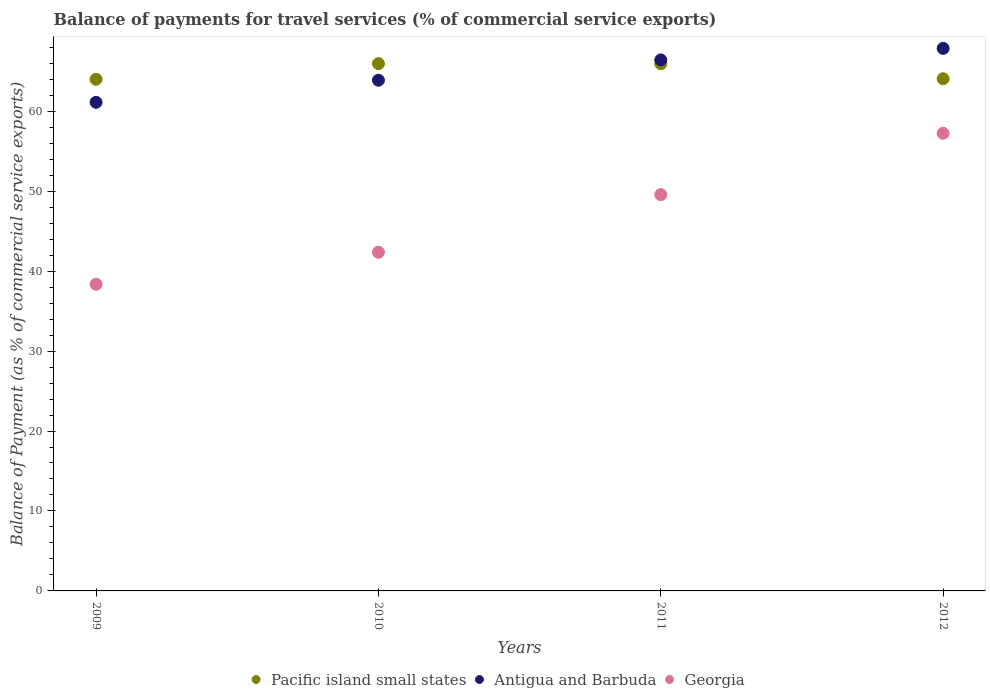What is the balance of payments for travel services in Antigua and Barbuda in 2009?
Ensure brevity in your answer.  61.11. Across all years, what is the maximum balance of payments for travel services in Georgia?
Your answer should be very brief. 57.23. Across all years, what is the minimum balance of payments for travel services in Antigua and Barbuda?
Provide a succinct answer. 61.11. In which year was the balance of payments for travel services in Antigua and Barbuda minimum?
Keep it short and to the point. 2009. What is the total balance of payments for travel services in Georgia in the graph?
Make the answer very short. 187.51. What is the difference between the balance of payments for travel services in Pacific island small states in 2009 and that in 2010?
Offer a terse response. -1.95. What is the difference between the balance of payments for travel services in Antigua and Barbuda in 2011 and the balance of payments for travel services in Pacific island small states in 2009?
Offer a very short reply. 2.42. What is the average balance of payments for travel services in Antigua and Barbuda per year?
Offer a terse response. 64.82. In the year 2012, what is the difference between the balance of payments for travel services in Pacific island small states and balance of payments for travel services in Antigua and Barbuda?
Your answer should be compact. -3.8. What is the ratio of the balance of payments for travel services in Antigua and Barbuda in 2010 to that in 2012?
Offer a very short reply. 0.94. Is the difference between the balance of payments for travel services in Pacific island small states in 2009 and 2011 greater than the difference between the balance of payments for travel services in Antigua and Barbuda in 2009 and 2011?
Ensure brevity in your answer.  Yes. What is the difference between the highest and the second highest balance of payments for travel services in Georgia?
Make the answer very short. 7.67. What is the difference between the highest and the lowest balance of payments for travel services in Pacific island small states?
Keep it short and to the point. 1.95. Does the balance of payments for travel services in Pacific island small states monotonically increase over the years?
Offer a very short reply. No. Is the balance of payments for travel services in Georgia strictly less than the balance of payments for travel services in Pacific island small states over the years?
Make the answer very short. Yes. How many dotlines are there?
Provide a short and direct response. 3. How many years are there in the graph?
Your answer should be very brief. 4. Are the values on the major ticks of Y-axis written in scientific E-notation?
Offer a terse response. No. Does the graph contain any zero values?
Ensure brevity in your answer.  No. Where does the legend appear in the graph?
Provide a short and direct response. Bottom center. What is the title of the graph?
Your answer should be very brief. Balance of payments for travel services (% of commercial service exports). What is the label or title of the Y-axis?
Offer a very short reply. Balance of Payment (as % of commercial service exports). What is the Balance of Payment (as % of commercial service exports) in Pacific island small states in 2009?
Make the answer very short. 64. What is the Balance of Payment (as % of commercial service exports) in Antigua and Barbuda in 2009?
Ensure brevity in your answer.  61.11. What is the Balance of Payment (as % of commercial service exports) of Georgia in 2009?
Your answer should be very brief. 38.36. What is the Balance of Payment (as % of commercial service exports) in Pacific island small states in 2010?
Provide a short and direct response. 65.95. What is the Balance of Payment (as % of commercial service exports) of Antigua and Barbuda in 2010?
Your answer should be very brief. 63.88. What is the Balance of Payment (as % of commercial service exports) in Georgia in 2010?
Your answer should be compact. 42.36. What is the Balance of Payment (as % of commercial service exports) in Pacific island small states in 2011?
Your response must be concise. 65.93. What is the Balance of Payment (as % of commercial service exports) in Antigua and Barbuda in 2011?
Your answer should be very brief. 66.42. What is the Balance of Payment (as % of commercial service exports) in Georgia in 2011?
Make the answer very short. 49.56. What is the Balance of Payment (as % of commercial service exports) of Pacific island small states in 2012?
Offer a terse response. 64.06. What is the Balance of Payment (as % of commercial service exports) of Antigua and Barbuda in 2012?
Provide a short and direct response. 67.86. What is the Balance of Payment (as % of commercial service exports) in Georgia in 2012?
Provide a succinct answer. 57.23. Across all years, what is the maximum Balance of Payment (as % of commercial service exports) in Pacific island small states?
Make the answer very short. 65.95. Across all years, what is the maximum Balance of Payment (as % of commercial service exports) of Antigua and Barbuda?
Your answer should be very brief. 67.86. Across all years, what is the maximum Balance of Payment (as % of commercial service exports) in Georgia?
Your answer should be very brief. 57.23. Across all years, what is the minimum Balance of Payment (as % of commercial service exports) in Pacific island small states?
Ensure brevity in your answer.  64. Across all years, what is the minimum Balance of Payment (as % of commercial service exports) of Antigua and Barbuda?
Ensure brevity in your answer.  61.11. Across all years, what is the minimum Balance of Payment (as % of commercial service exports) in Georgia?
Your answer should be very brief. 38.36. What is the total Balance of Payment (as % of commercial service exports) of Pacific island small states in the graph?
Your answer should be compact. 259.93. What is the total Balance of Payment (as % of commercial service exports) in Antigua and Barbuda in the graph?
Your answer should be compact. 259.26. What is the total Balance of Payment (as % of commercial service exports) in Georgia in the graph?
Ensure brevity in your answer.  187.51. What is the difference between the Balance of Payment (as % of commercial service exports) in Pacific island small states in 2009 and that in 2010?
Your answer should be compact. -1.95. What is the difference between the Balance of Payment (as % of commercial service exports) in Antigua and Barbuda in 2009 and that in 2010?
Your answer should be compact. -2.77. What is the difference between the Balance of Payment (as % of commercial service exports) in Georgia in 2009 and that in 2010?
Keep it short and to the point. -4.01. What is the difference between the Balance of Payment (as % of commercial service exports) of Pacific island small states in 2009 and that in 2011?
Your answer should be compact. -1.93. What is the difference between the Balance of Payment (as % of commercial service exports) of Antigua and Barbuda in 2009 and that in 2011?
Your answer should be compact. -5.3. What is the difference between the Balance of Payment (as % of commercial service exports) of Georgia in 2009 and that in 2011?
Your answer should be compact. -11.21. What is the difference between the Balance of Payment (as % of commercial service exports) of Pacific island small states in 2009 and that in 2012?
Offer a very short reply. -0.07. What is the difference between the Balance of Payment (as % of commercial service exports) in Antigua and Barbuda in 2009 and that in 2012?
Your response must be concise. -6.75. What is the difference between the Balance of Payment (as % of commercial service exports) of Georgia in 2009 and that in 2012?
Offer a terse response. -18.88. What is the difference between the Balance of Payment (as % of commercial service exports) in Pacific island small states in 2010 and that in 2011?
Offer a very short reply. 0.02. What is the difference between the Balance of Payment (as % of commercial service exports) of Antigua and Barbuda in 2010 and that in 2011?
Offer a terse response. -2.54. What is the difference between the Balance of Payment (as % of commercial service exports) of Georgia in 2010 and that in 2011?
Provide a succinct answer. -7.2. What is the difference between the Balance of Payment (as % of commercial service exports) of Pacific island small states in 2010 and that in 2012?
Your answer should be compact. 1.89. What is the difference between the Balance of Payment (as % of commercial service exports) in Antigua and Barbuda in 2010 and that in 2012?
Ensure brevity in your answer.  -3.98. What is the difference between the Balance of Payment (as % of commercial service exports) of Georgia in 2010 and that in 2012?
Give a very brief answer. -14.87. What is the difference between the Balance of Payment (as % of commercial service exports) of Pacific island small states in 2011 and that in 2012?
Your answer should be compact. 1.87. What is the difference between the Balance of Payment (as % of commercial service exports) of Antigua and Barbuda in 2011 and that in 2012?
Offer a terse response. -1.44. What is the difference between the Balance of Payment (as % of commercial service exports) in Georgia in 2011 and that in 2012?
Provide a succinct answer. -7.67. What is the difference between the Balance of Payment (as % of commercial service exports) of Pacific island small states in 2009 and the Balance of Payment (as % of commercial service exports) of Antigua and Barbuda in 2010?
Provide a succinct answer. 0.12. What is the difference between the Balance of Payment (as % of commercial service exports) of Pacific island small states in 2009 and the Balance of Payment (as % of commercial service exports) of Georgia in 2010?
Provide a succinct answer. 21.63. What is the difference between the Balance of Payment (as % of commercial service exports) in Antigua and Barbuda in 2009 and the Balance of Payment (as % of commercial service exports) in Georgia in 2010?
Provide a short and direct response. 18.75. What is the difference between the Balance of Payment (as % of commercial service exports) of Pacific island small states in 2009 and the Balance of Payment (as % of commercial service exports) of Antigua and Barbuda in 2011?
Offer a terse response. -2.42. What is the difference between the Balance of Payment (as % of commercial service exports) in Pacific island small states in 2009 and the Balance of Payment (as % of commercial service exports) in Georgia in 2011?
Offer a terse response. 14.43. What is the difference between the Balance of Payment (as % of commercial service exports) in Antigua and Barbuda in 2009 and the Balance of Payment (as % of commercial service exports) in Georgia in 2011?
Offer a very short reply. 11.55. What is the difference between the Balance of Payment (as % of commercial service exports) in Pacific island small states in 2009 and the Balance of Payment (as % of commercial service exports) in Antigua and Barbuda in 2012?
Make the answer very short. -3.86. What is the difference between the Balance of Payment (as % of commercial service exports) of Pacific island small states in 2009 and the Balance of Payment (as % of commercial service exports) of Georgia in 2012?
Your answer should be compact. 6.76. What is the difference between the Balance of Payment (as % of commercial service exports) in Antigua and Barbuda in 2009 and the Balance of Payment (as % of commercial service exports) in Georgia in 2012?
Offer a very short reply. 3.88. What is the difference between the Balance of Payment (as % of commercial service exports) of Pacific island small states in 2010 and the Balance of Payment (as % of commercial service exports) of Antigua and Barbuda in 2011?
Provide a short and direct response. -0.47. What is the difference between the Balance of Payment (as % of commercial service exports) in Pacific island small states in 2010 and the Balance of Payment (as % of commercial service exports) in Georgia in 2011?
Your answer should be very brief. 16.39. What is the difference between the Balance of Payment (as % of commercial service exports) of Antigua and Barbuda in 2010 and the Balance of Payment (as % of commercial service exports) of Georgia in 2011?
Give a very brief answer. 14.32. What is the difference between the Balance of Payment (as % of commercial service exports) of Pacific island small states in 2010 and the Balance of Payment (as % of commercial service exports) of Antigua and Barbuda in 2012?
Your response must be concise. -1.91. What is the difference between the Balance of Payment (as % of commercial service exports) of Pacific island small states in 2010 and the Balance of Payment (as % of commercial service exports) of Georgia in 2012?
Make the answer very short. 8.71. What is the difference between the Balance of Payment (as % of commercial service exports) in Antigua and Barbuda in 2010 and the Balance of Payment (as % of commercial service exports) in Georgia in 2012?
Your answer should be very brief. 6.64. What is the difference between the Balance of Payment (as % of commercial service exports) of Pacific island small states in 2011 and the Balance of Payment (as % of commercial service exports) of Antigua and Barbuda in 2012?
Your answer should be very brief. -1.93. What is the difference between the Balance of Payment (as % of commercial service exports) of Pacific island small states in 2011 and the Balance of Payment (as % of commercial service exports) of Georgia in 2012?
Provide a succinct answer. 8.7. What is the difference between the Balance of Payment (as % of commercial service exports) of Antigua and Barbuda in 2011 and the Balance of Payment (as % of commercial service exports) of Georgia in 2012?
Provide a succinct answer. 9.18. What is the average Balance of Payment (as % of commercial service exports) of Pacific island small states per year?
Keep it short and to the point. 64.98. What is the average Balance of Payment (as % of commercial service exports) in Antigua and Barbuda per year?
Provide a succinct answer. 64.82. What is the average Balance of Payment (as % of commercial service exports) of Georgia per year?
Ensure brevity in your answer.  46.88. In the year 2009, what is the difference between the Balance of Payment (as % of commercial service exports) in Pacific island small states and Balance of Payment (as % of commercial service exports) in Antigua and Barbuda?
Give a very brief answer. 2.88. In the year 2009, what is the difference between the Balance of Payment (as % of commercial service exports) of Pacific island small states and Balance of Payment (as % of commercial service exports) of Georgia?
Keep it short and to the point. 25.64. In the year 2009, what is the difference between the Balance of Payment (as % of commercial service exports) of Antigua and Barbuda and Balance of Payment (as % of commercial service exports) of Georgia?
Your answer should be compact. 22.76. In the year 2010, what is the difference between the Balance of Payment (as % of commercial service exports) of Pacific island small states and Balance of Payment (as % of commercial service exports) of Antigua and Barbuda?
Keep it short and to the point. 2.07. In the year 2010, what is the difference between the Balance of Payment (as % of commercial service exports) in Pacific island small states and Balance of Payment (as % of commercial service exports) in Georgia?
Your answer should be compact. 23.59. In the year 2010, what is the difference between the Balance of Payment (as % of commercial service exports) in Antigua and Barbuda and Balance of Payment (as % of commercial service exports) in Georgia?
Offer a very short reply. 21.51. In the year 2011, what is the difference between the Balance of Payment (as % of commercial service exports) of Pacific island small states and Balance of Payment (as % of commercial service exports) of Antigua and Barbuda?
Ensure brevity in your answer.  -0.49. In the year 2011, what is the difference between the Balance of Payment (as % of commercial service exports) in Pacific island small states and Balance of Payment (as % of commercial service exports) in Georgia?
Make the answer very short. 16.37. In the year 2011, what is the difference between the Balance of Payment (as % of commercial service exports) of Antigua and Barbuda and Balance of Payment (as % of commercial service exports) of Georgia?
Your answer should be very brief. 16.86. In the year 2012, what is the difference between the Balance of Payment (as % of commercial service exports) of Pacific island small states and Balance of Payment (as % of commercial service exports) of Antigua and Barbuda?
Offer a terse response. -3.8. In the year 2012, what is the difference between the Balance of Payment (as % of commercial service exports) of Pacific island small states and Balance of Payment (as % of commercial service exports) of Georgia?
Give a very brief answer. 6.83. In the year 2012, what is the difference between the Balance of Payment (as % of commercial service exports) in Antigua and Barbuda and Balance of Payment (as % of commercial service exports) in Georgia?
Your answer should be very brief. 10.63. What is the ratio of the Balance of Payment (as % of commercial service exports) in Pacific island small states in 2009 to that in 2010?
Provide a short and direct response. 0.97. What is the ratio of the Balance of Payment (as % of commercial service exports) in Antigua and Barbuda in 2009 to that in 2010?
Offer a terse response. 0.96. What is the ratio of the Balance of Payment (as % of commercial service exports) of Georgia in 2009 to that in 2010?
Your answer should be very brief. 0.91. What is the ratio of the Balance of Payment (as % of commercial service exports) of Pacific island small states in 2009 to that in 2011?
Your answer should be compact. 0.97. What is the ratio of the Balance of Payment (as % of commercial service exports) of Antigua and Barbuda in 2009 to that in 2011?
Offer a very short reply. 0.92. What is the ratio of the Balance of Payment (as % of commercial service exports) in Georgia in 2009 to that in 2011?
Provide a short and direct response. 0.77. What is the ratio of the Balance of Payment (as % of commercial service exports) of Pacific island small states in 2009 to that in 2012?
Your answer should be compact. 1. What is the ratio of the Balance of Payment (as % of commercial service exports) in Antigua and Barbuda in 2009 to that in 2012?
Your answer should be very brief. 0.9. What is the ratio of the Balance of Payment (as % of commercial service exports) in Georgia in 2009 to that in 2012?
Offer a very short reply. 0.67. What is the ratio of the Balance of Payment (as % of commercial service exports) in Pacific island small states in 2010 to that in 2011?
Keep it short and to the point. 1. What is the ratio of the Balance of Payment (as % of commercial service exports) of Antigua and Barbuda in 2010 to that in 2011?
Provide a short and direct response. 0.96. What is the ratio of the Balance of Payment (as % of commercial service exports) of Georgia in 2010 to that in 2011?
Make the answer very short. 0.85. What is the ratio of the Balance of Payment (as % of commercial service exports) in Pacific island small states in 2010 to that in 2012?
Your answer should be very brief. 1.03. What is the ratio of the Balance of Payment (as % of commercial service exports) in Antigua and Barbuda in 2010 to that in 2012?
Offer a very short reply. 0.94. What is the ratio of the Balance of Payment (as % of commercial service exports) of Georgia in 2010 to that in 2012?
Keep it short and to the point. 0.74. What is the ratio of the Balance of Payment (as % of commercial service exports) of Pacific island small states in 2011 to that in 2012?
Provide a short and direct response. 1.03. What is the ratio of the Balance of Payment (as % of commercial service exports) in Antigua and Barbuda in 2011 to that in 2012?
Your response must be concise. 0.98. What is the ratio of the Balance of Payment (as % of commercial service exports) in Georgia in 2011 to that in 2012?
Provide a short and direct response. 0.87. What is the difference between the highest and the second highest Balance of Payment (as % of commercial service exports) of Pacific island small states?
Give a very brief answer. 0.02. What is the difference between the highest and the second highest Balance of Payment (as % of commercial service exports) in Antigua and Barbuda?
Provide a short and direct response. 1.44. What is the difference between the highest and the second highest Balance of Payment (as % of commercial service exports) in Georgia?
Your answer should be very brief. 7.67. What is the difference between the highest and the lowest Balance of Payment (as % of commercial service exports) in Pacific island small states?
Your answer should be compact. 1.95. What is the difference between the highest and the lowest Balance of Payment (as % of commercial service exports) in Antigua and Barbuda?
Ensure brevity in your answer.  6.75. What is the difference between the highest and the lowest Balance of Payment (as % of commercial service exports) in Georgia?
Provide a short and direct response. 18.88. 